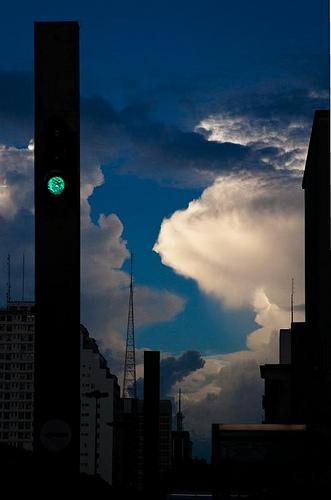Is the sky blue or white?
Write a very short answer. Blue. Is there a clock on the picture?
Short answer required. Yes. Are clouds in the sky?
Answer briefly. Yes. Is the traffic light signaling to slow down?
Write a very short answer. No. 